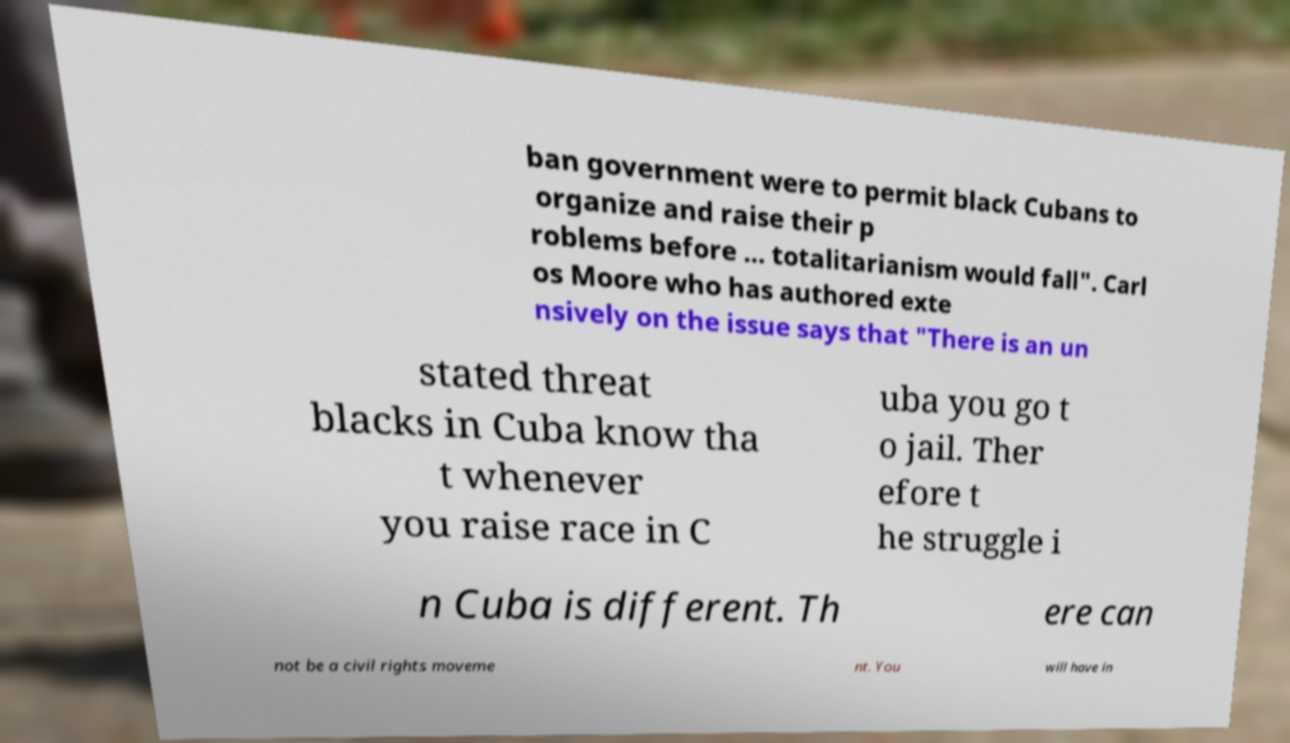For documentation purposes, I need the text within this image transcribed. Could you provide that? ban government were to permit black Cubans to organize and raise their p roblems before ... totalitarianism would fall". Carl os Moore who has authored exte nsively on the issue says that "There is an un stated threat blacks in Cuba know tha t whenever you raise race in C uba you go t o jail. Ther efore t he struggle i n Cuba is different. Th ere can not be a civil rights moveme nt. You will have in 